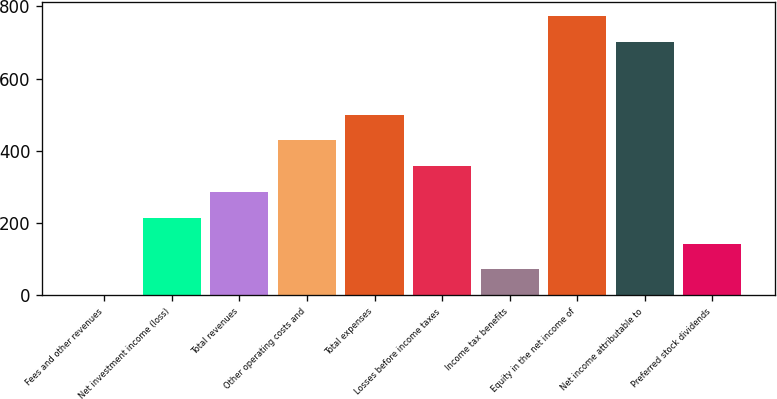Convert chart to OTSL. <chart><loc_0><loc_0><loc_500><loc_500><bar_chart><fcel>Fees and other revenues<fcel>Net investment income (loss)<fcel>Total revenues<fcel>Other operating costs and<fcel>Total expenses<fcel>Losses before income taxes<fcel>Income tax benefits<fcel>Equity in the net income of<fcel>Net income attributable to<fcel>Preferred stock dividends<nl><fcel>0.1<fcel>214.36<fcel>285.78<fcel>428.62<fcel>500.04<fcel>357.2<fcel>71.52<fcel>772.74<fcel>701.32<fcel>142.94<nl></chart> 